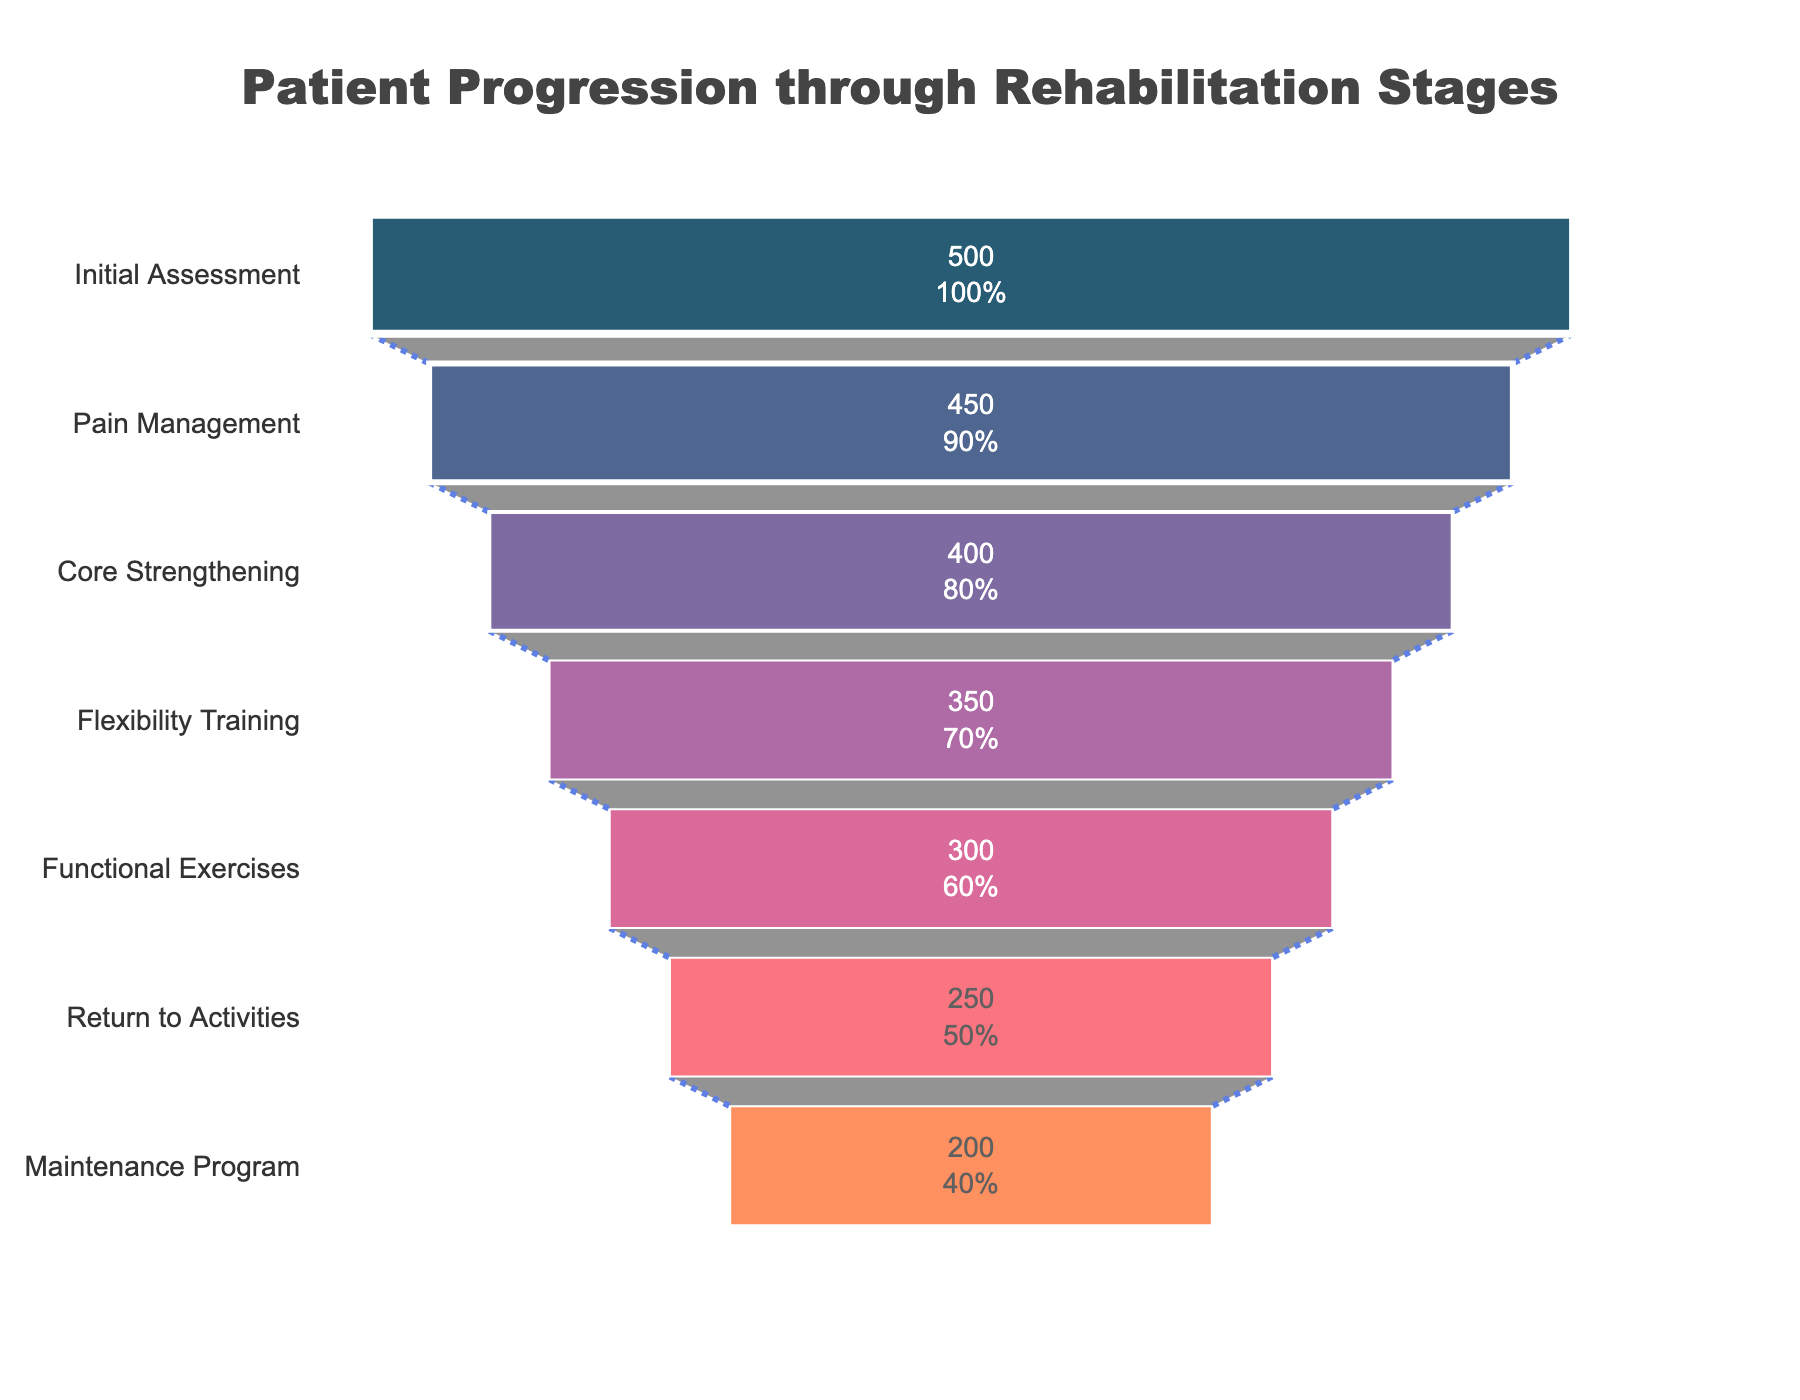What is the title of the funnel chart? The title of the funnel chart is displayed prominently at the top center of the figure. It provides a summary of what the chart depicts. The title reads "Patient Progression through Rehabilitation Stages."
Answer: Patient Progression through Rehabilitation Stages What is the number of patients at the Initial Assessment stage? Referring to the first stage of the funnel chart, the data indicates the number of patients who started the rehabilitation process. For the Initial Assessment stage, there are 500 patients.
Answer: 500 How many patients progressed from Pain Management to Core Strengthening? To find this, we check the number of patients in Pain Management (450) and compare it to those in Core Strengthening (400). The difference, representing the number of patients who progressed, is calculated as 450 - 400.
Answer: 50 What percentage of patients remained in the rehabilitation program after Flexibility Training? First, we find the number of patients who reached Flexibility Training (350) and those who continued to Functional Exercises (300). To calculate the percentage, we use the formula: (300 / 350) * 100%.
Answer: 85.71% Which rehabilitation stage had the highest drop-off in patients? To determine this, we observe the differences between consecutive stages and identify the largest drop. The largest drop occurs between Initial Assessment (500) and Pain Management (450), with a drop of 50 patients.
Answer: Initial Assessment to Pain Management What is the total number of patients who completed the rehabilitation program? The stage that indicates completion is the Maintenance Program. Looking at this stage, we find that 200 patients have reached it, indicating the total number of completions.
Answer: 200 How many more patients reached Core Strengthening than Functional Exercises? This requires comparing the number of patients at the Core Strengthening (400) and Functional Exercises (300) stages. The difference is calculated as 400 - 300.
Answer: 100 Which stage has the lowest number of patients? By examining the number of patients at each stage, we see that the Maintenance Program stage has the lowest count with 200 patients.
Answer: Maintenance Program What percentage of patients remained in the rehabilitation program from the Initial Assessment to Pain Management? To find this percentage, we divide the number of patients in Pain Management (450) by the number of patients in the Initial Assessment (500) and multiply by 100: (450 / 500) * 100%.
Answer: 90% What is the total number of stages in the rehabilitation program? Counting the distinct stages listed in the funnel chart gives us the total number of stages. These are: Initial Assessment, Pain Management, Core Strengthening, Flexibility Training, Functional Exercises, Return to Activities, and Maintenance Program. The total is 7.
Answer: 7 